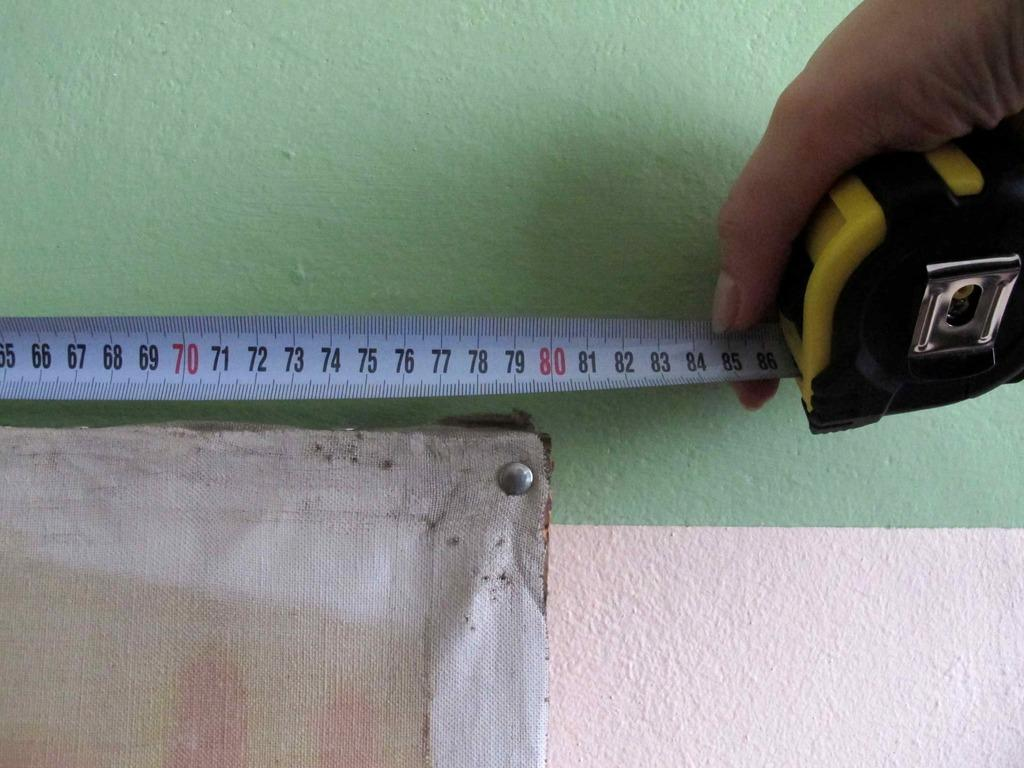<image>
Summarize the visual content of the image. A person is measuring an item that is 80 centimeters long. 